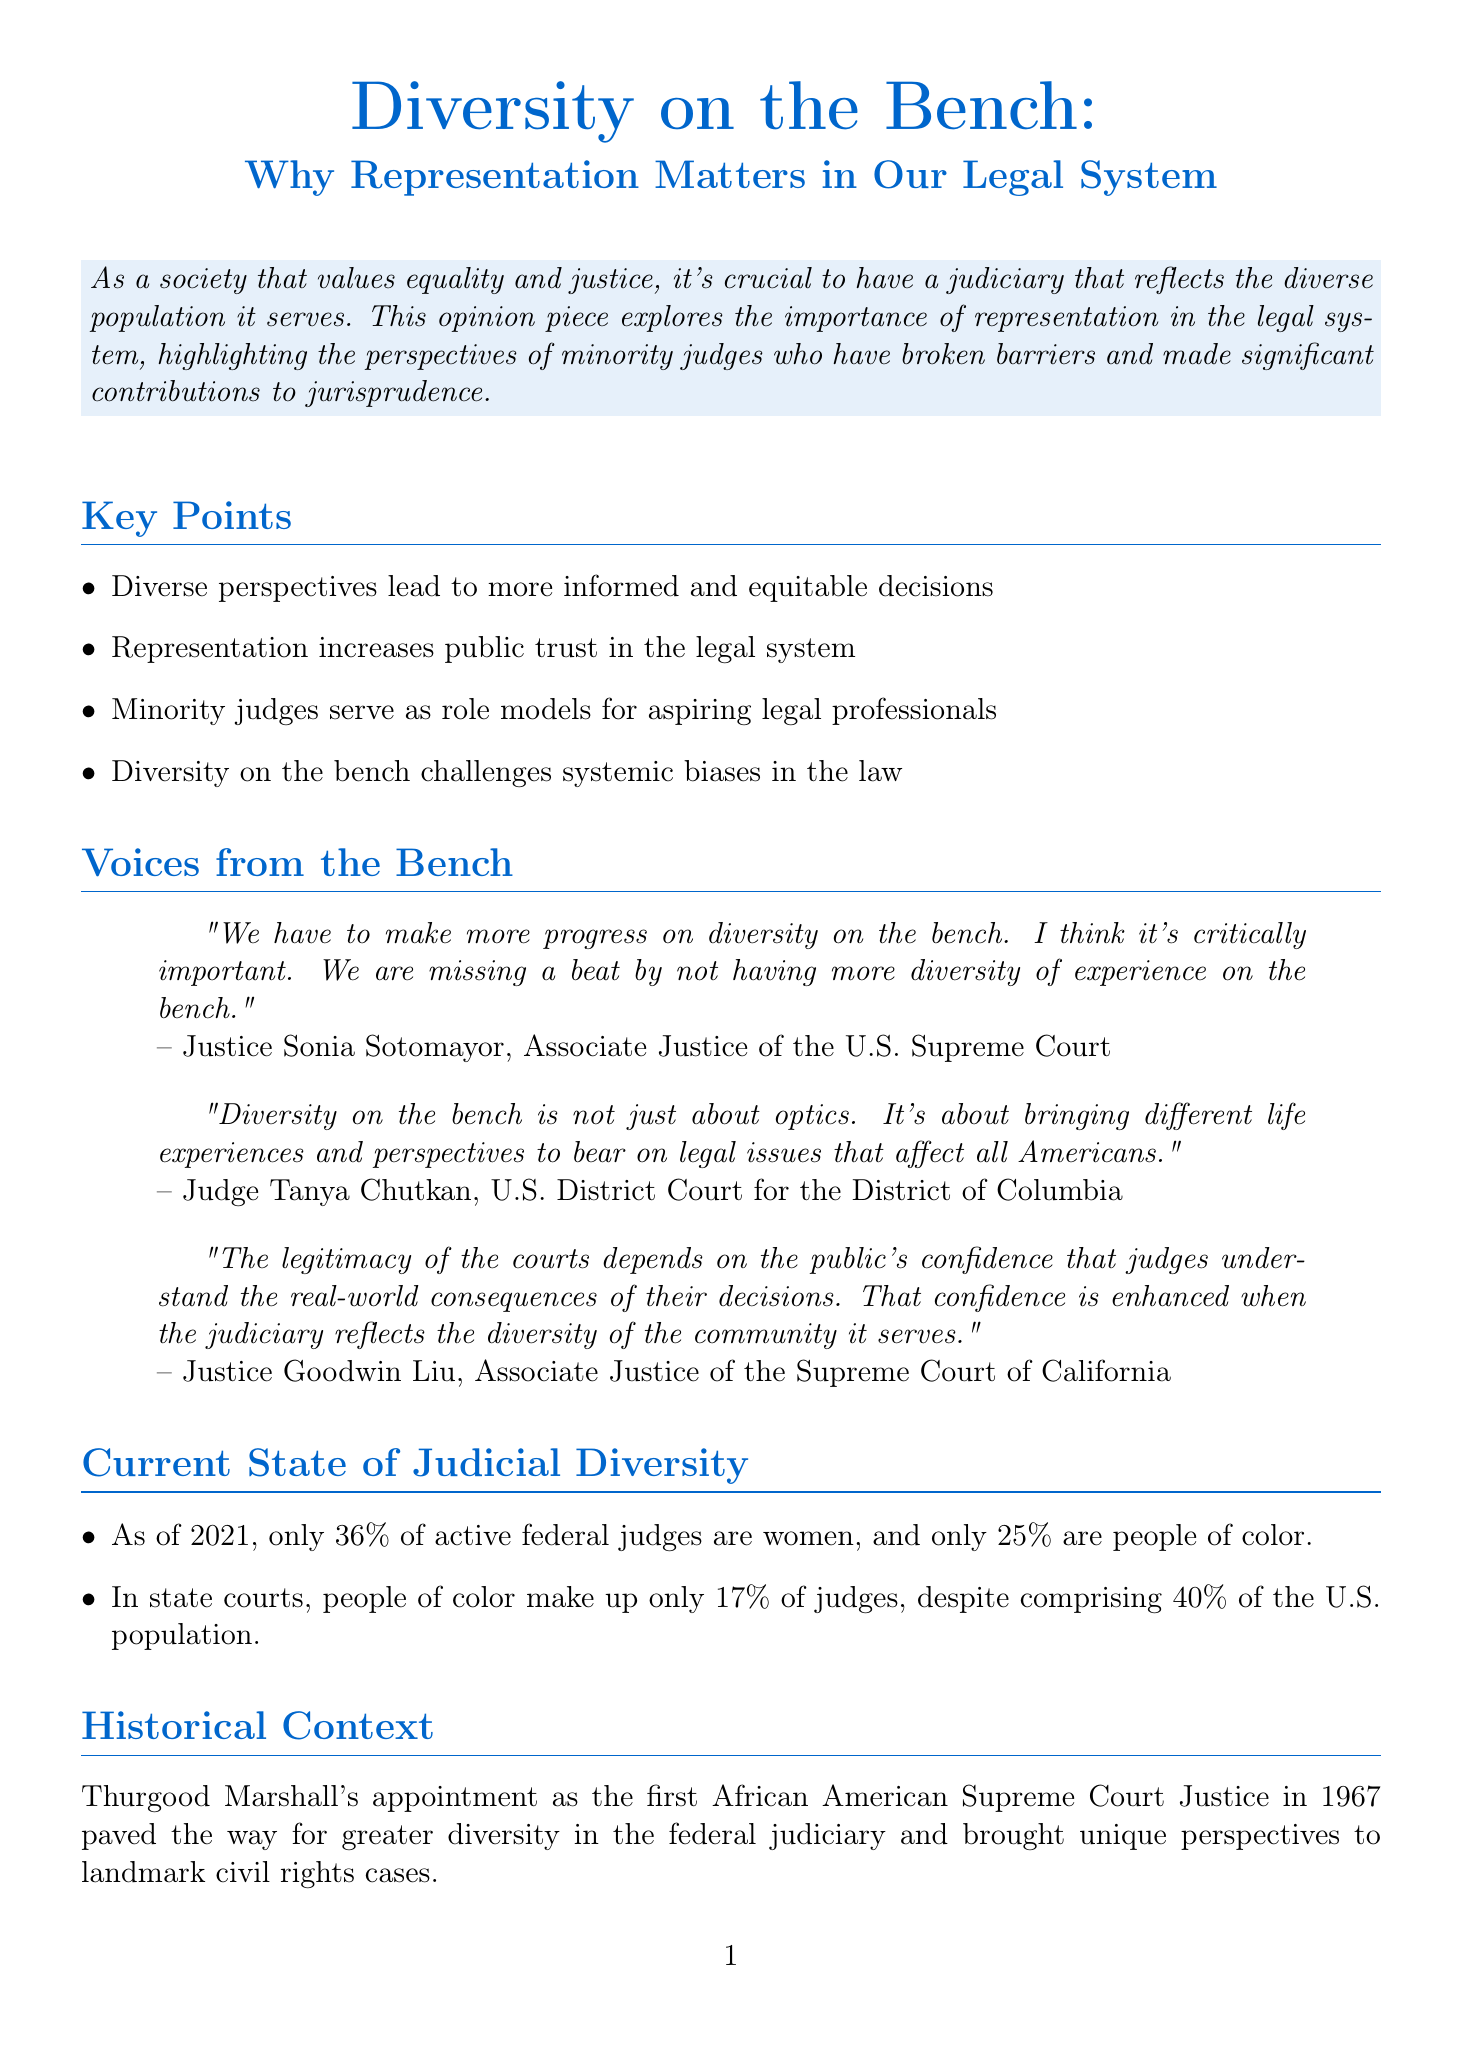What is the title of the opinion piece? The title is explicitly stated at the beginning of the document.
Answer: Diversity on the Bench: Why Representation Matters in Our Legal System Who is the author of the opinion piece? The author’s name and credentials are provided at the end of the document.
Answer: Maya Rodriguez What percentage of active federal judges are women as of 2021? The document includes specific statistics about the diversity of federal judges.
Answer: 36% What initiative encourages law students of color to pursue judicial clerkships? The document describes current initiatives to promote diversity in the judiciary.
Answer: American Bar Association Judicial Clerkship Program According to Justice Goodwin Liu, what enhances public confidence in the judiciary? This quote outlines a reasoning related to the importance of representation among judges.
Answer: Diversity of the community it serves What historic milestone is mentioned in the document regarding judicial diversity? The document references a significant historical figure related to diversity in the legal system.
Answer: Thurgood Marshall's appointment as the first African American Supreme Court Justice in 1967 What is one challenge identified in increasing diversity in the judiciary? The document outlines specific challenges faced in this pursuit of diversity.
Answer: Political polarization in the judicial nomination process What is the call to action in the opinion piece? The call to action summarizes the main recommendation provided in the conclusion of the document.
Answer: Advocate for increased diversity in judicial nominations 